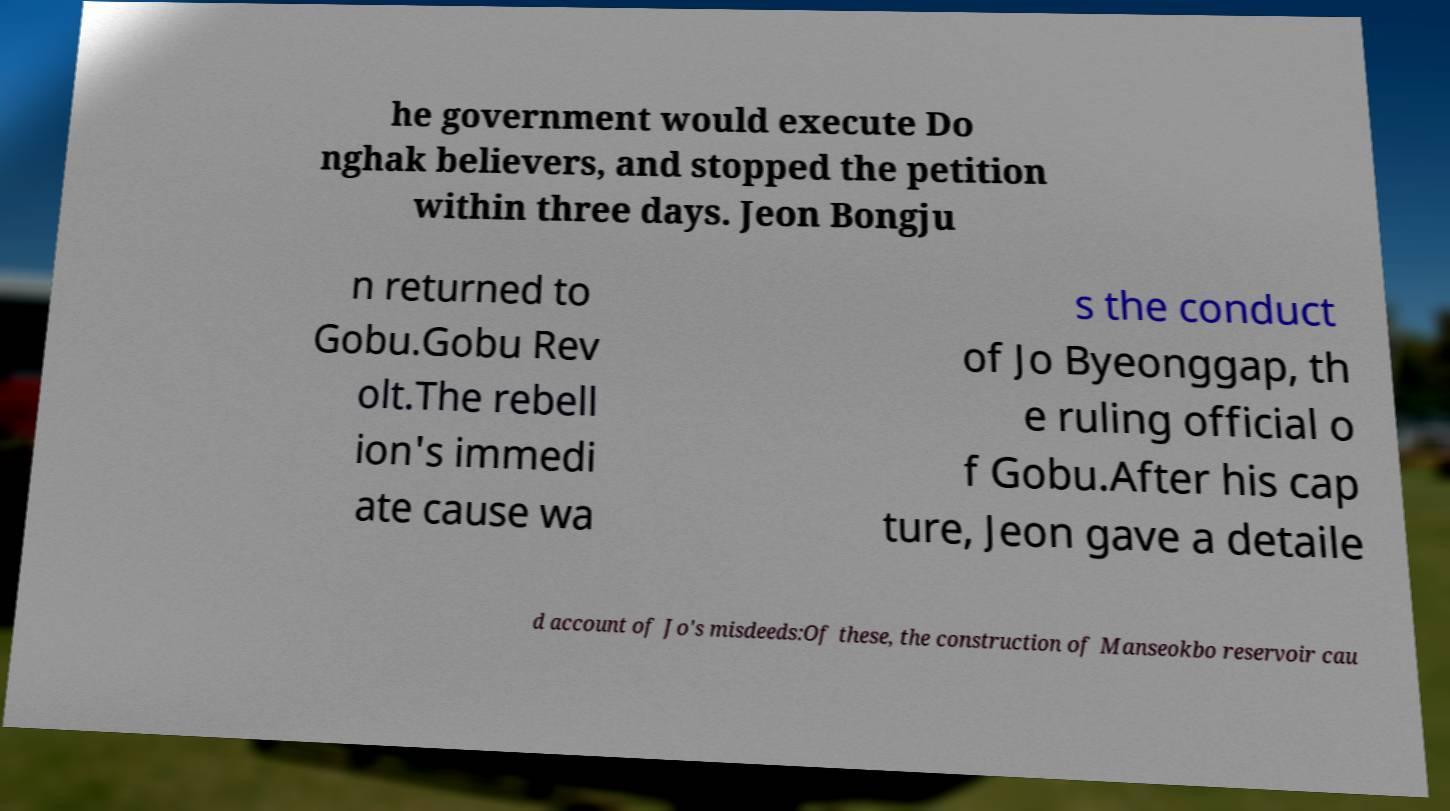What messages or text are displayed in this image? I need them in a readable, typed format. he government would execute Do nghak believers, and stopped the petition within three days. Jeon Bongju n returned to Gobu.Gobu Rev olt.The rebell ion's immedi ate cause wa s the conduct of Jo Byeonggap, th e ruling official o f Gobu.After his cap ture, Jeon gave a detaile d account of Jo's misdeeds:Of these, the construction of Manseokbo reservoir cau 